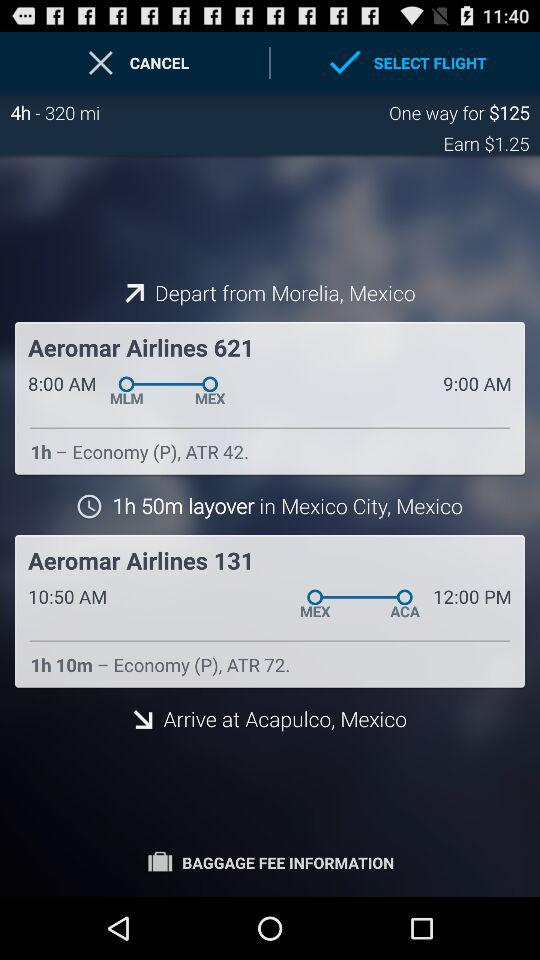What is the departure city of "Aeromar Airlines 131"? The departure city is Mexico City, Mexico. 